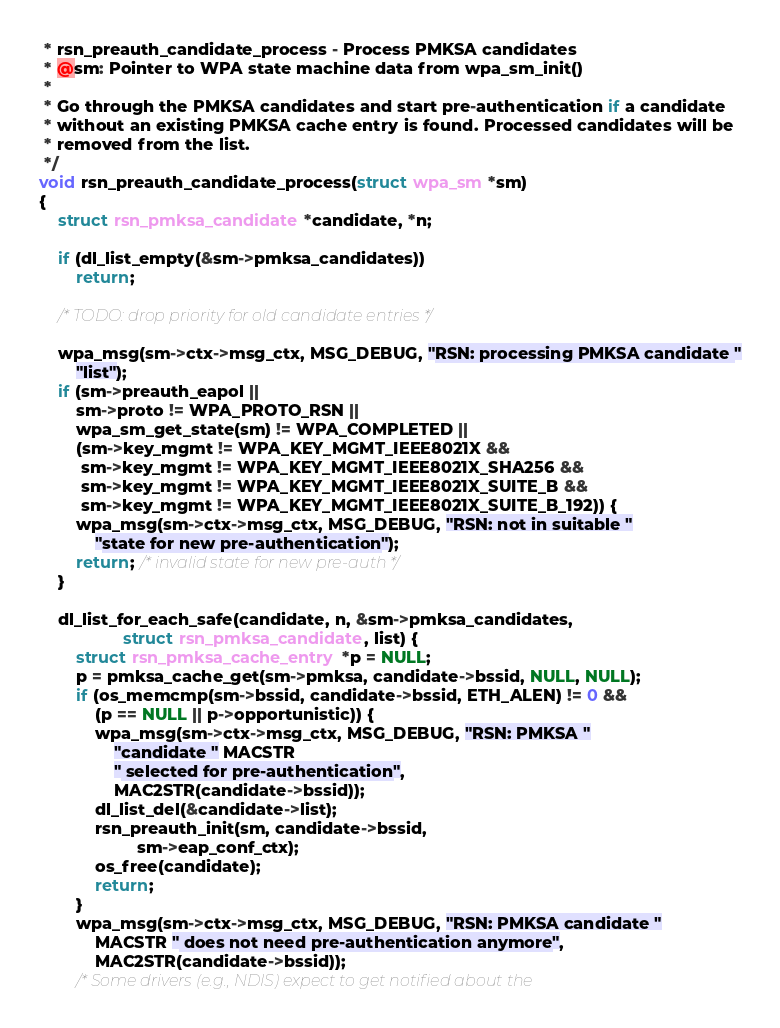Convert code to text. <code><loc_0><loc_0><loc_500><loc_500><_C_> * rsn_preauth_candidate_process - Process PMKSA candidates
 * @sm: Pointer to WPA state machine data from wpa_sm_init()
 *
 * Go through the PMKSA candidates and start pre-authentication if a candidate
 * without an existing PMKSA cache entry is found. Processed candidates will be
 * removed from the list.
 */
void rsn_preauth_candidate_process(struct wpa_sm *sm)
{
	struct rsn_pmksa_candidate *candidate, *n;

	if (dl_list_empty(&sm->pmksa_candidates))
		return;

	/* TODO: drop priority for old candidate entries */

	wpa_msg(sm->ctx->msg_ctx, MSG_DEBUG, "RSN: processing PMKSA candidate "
		"list");
	if (sm->preauth_eapol ||
	    sm->proto != WPA_PROTO_RSN ||
	    wpa_sm_get_state(sm) != WPA_COMPLETED ||
	    (sm->key_mgmt != WPA_KEY_MGMT_IEEE8021X &&
	     sm->key_mgmt != WPA_KEY_MGMT_IEEE8021X_SHA256 &&
	     sm->key_mgmt != WPA_KEY_MGMT_IEEE8021X_SUITE_B &&
	     sm->key_mgmt != WPA_KEY_MGMT_IEEE8021X_SUITE_B_192)) {
		wpa_msg(sm->ctx->msg_ctx, MSG_DEBUG, "RSN: not in suitable "
			"state for new pre-authentication");
		return; /* invalid state for new pre-auth */
	}

	dl_list_for_each_safe(candidate, n, &sm->pmksa_candidates,
			      struct rsn_pmksa_candidate, list) {
		struct rsn_pmksa_cache_entry *p = NULL;
		p = pmksa_cache_get(sm->pmksa, candidate->bssid, NULL, NULL);
		if (os_memcmp(sm->bssid, candidate->bssid, ETH_ALEN) != 0 &&
		    (p == NULL || p->opportunistic)) {
			wpa_msg(sm->ctx->msg_ctx, MSG_DEBUG, "RSN: PMKSA "
				"candidate " MACSTR
				" selected for pre-authentication",
				MAC2STR(candidate->bssid));
			dl_list_del(&candidate->list);
			rsn_preauth_init(sm, candidate->bssid,
					 sm->eap_conf_ctx);
			os_free(candidate);
			return;
		}
		wpa_msg(sm->ctx->msg_ctx, MSG_DEBUG, "RSN: PMKSA candidate "
			MACSTR " does not need pre-authentication anymore",
			MAC2STR(candidate->bssid));
		/* Some drivers (e.g., NDIS) expect to get notified about the</code> 